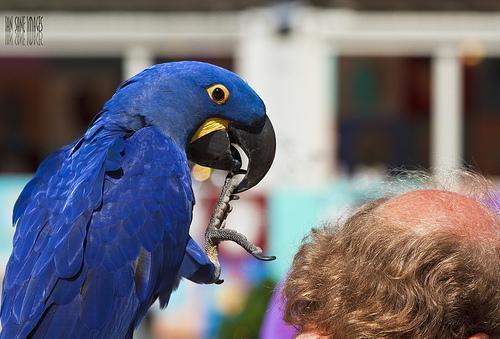How many parrots are there?
Give a very brief answer. 1. How many colors is the parrot?
Give a very brief answer. 3. 